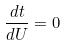Convert formula to latex. <formula><loc_0><loc_0><loc_500><loc_500>\frac { d t } { d U } = 0</formula> 